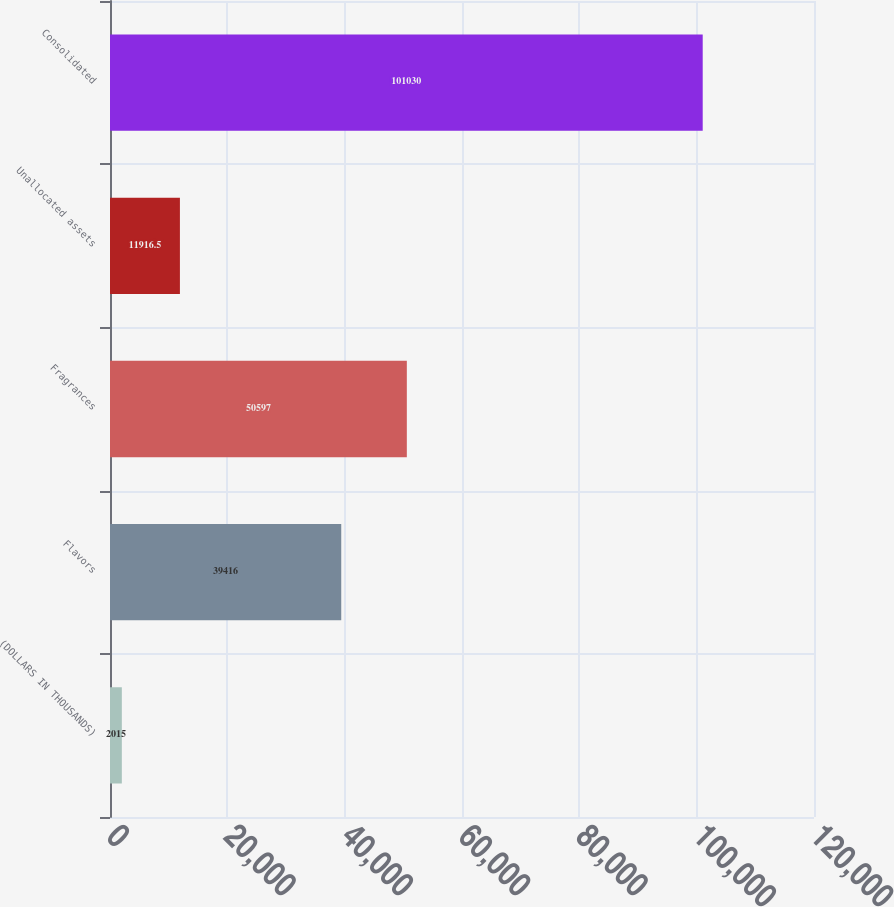Convert chart to OTSL. <chart><loc_0><loc_0><loc_500><loc_500><bar_chart><fcel>(DOLLARS IN THOUSANDS)<fcel>Flavors<fcel>Fragrances<fcel>Unallocated assets<fcel>Consolidated<nl><fcel>2015<fcel>39416<fcel>50597<fcel>11916.5<fcel>101030<nl></chart> 